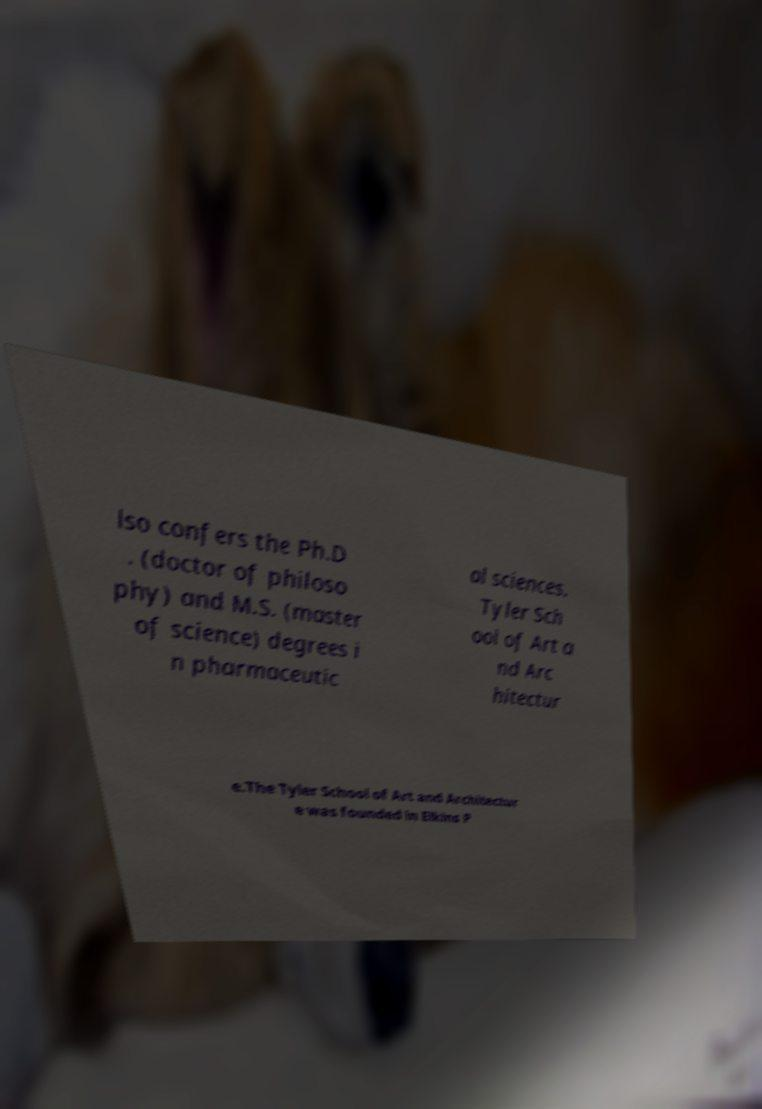What messages or text are displayed in this image? I need them in a readable, typed format. lso confers the Ph.D . (doctor of philoso phy) and M.S. (master of science) degrees i n pharmaceutic al sciences. Tyler Sch ool of Art a nd Arc hitectur e.The Tyler School of Art and Architectur e was founded in Elkins P 